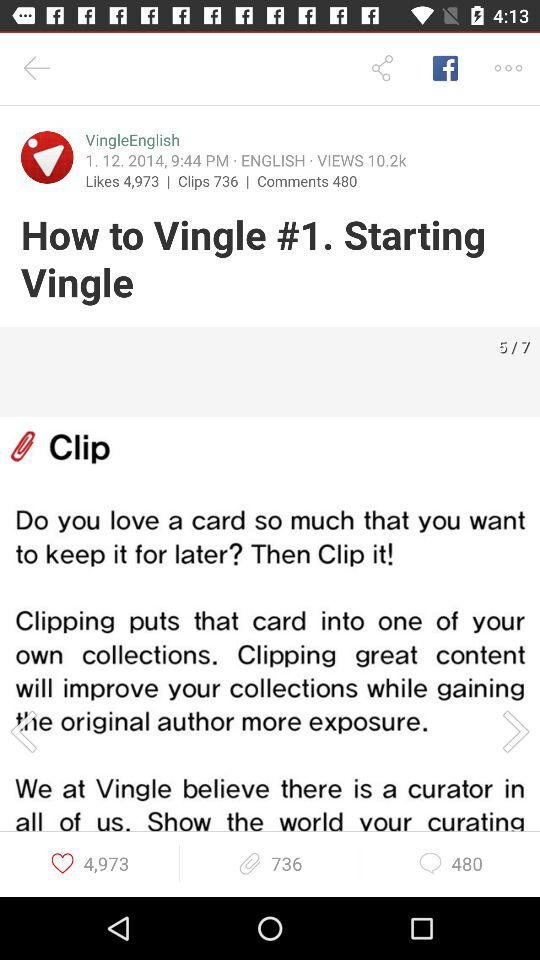How many views are there on the post by "VingleEnglish"? There are 10.2k views on the post by "VingleEnglish". 